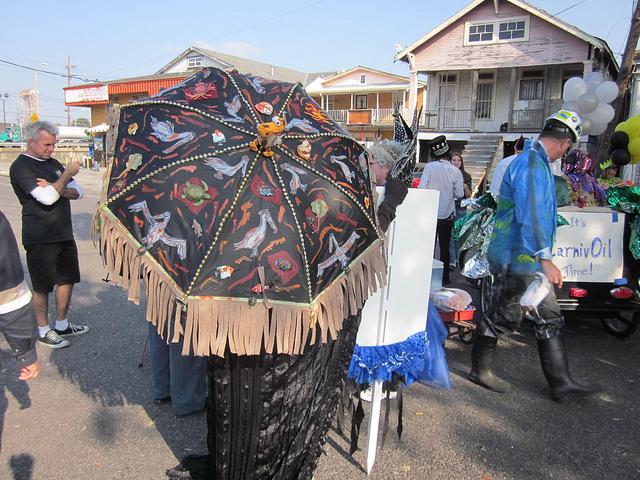Is the umbrella open?
Be succinct. Yes. How many people are holding umbrellas?
Give a very brief answer. 1. What type of footwear does the man in the blue shirt wear?
Write a very short answer. Boots. 